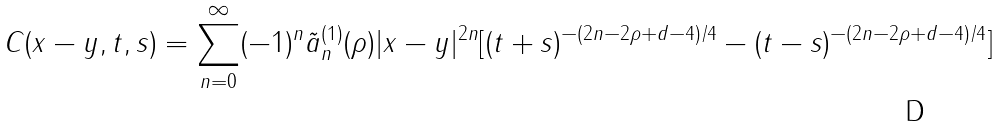<formula> <loc_0><loc_0><loc_500><loc_500>C ( x - y , t , s ) = \sum _ { n = 0 } ^ { \infty } ( - 1 ) ^ { n } \tilde { a } _ { n } ^ { ( 1 ) } ( \rho ) | x - y | ^ { 2 n } [ ( t + s ) ^ { - ( 2 n - 2 \rho + d - 4 ) / 4 } - ( t - s ) ^ { - ( 2 n - 2 \rho + d - 4 ) / 4 } ]</formula> 